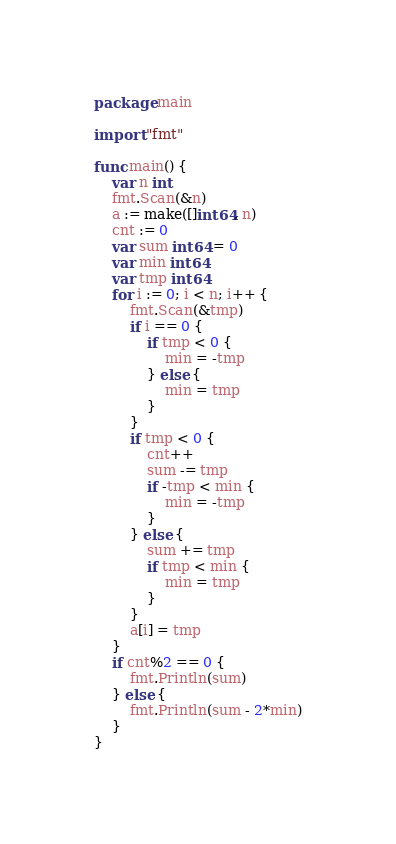<code> <loc_0><loc_0><loc_500><loc_500><_Go_>package main

import "fmt"

func main() {
	var n int
	fmt.Scan(&n)
	a := make([]int64, n)
	cnt := 0
	var sum int64 = 0
	var min int64
	var tmp int64
	for i := 0; i < n; i++ {
		fmt.Scan(&tmp)
		if i == 0 {
			if tmp < 0 {
				min = -tmp
			} else {
				min = tmp
			}
		}
		if tmp < 0 {
			cnt++
			sum -= tmp
			if -tmp < min {
				min = -tmp
			}
		} else {
			sum += tmp
			if tmp < min {
				min = tmp
			}
		}
		a[i] = tmp
	}
	if cnt%2 == 0 {
		fmt.Println(sum)
	} else {
		fmt.Println(sum - 2*min)
	}
}
</code> 